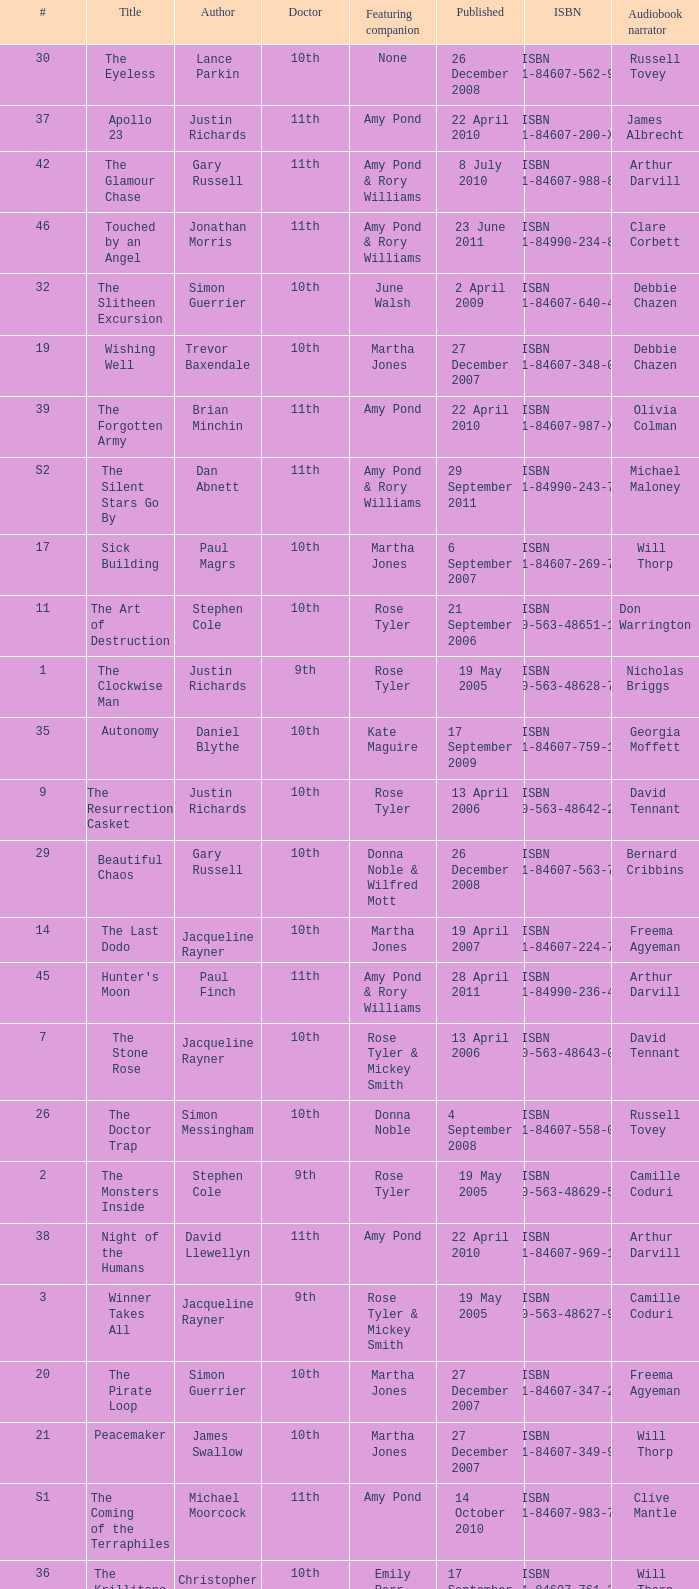Who are the featuring companions of number 3? Rose Tyler & Mickey Smith. 